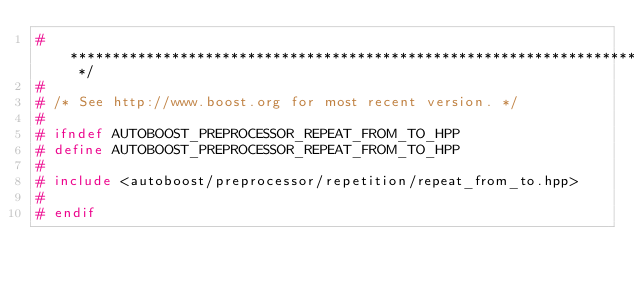<code> <loc_0><loc_0><loc_500><loc_500><_C++_>#  ************************************************************************** */
#
# /* See http://www.boost.org for most recent version. */
#
# ifndef AUTOBOOST_PREPROCESSOR_REPEAT_FROM_TO_HPP
# define AUTOBOOST_PREPROCESSOR_REPEAT_FROM_TO_HPP
#
# include <autoboost/preprocessor/repetition/repeat_from_to.hpp>
#
# endif
</code> 